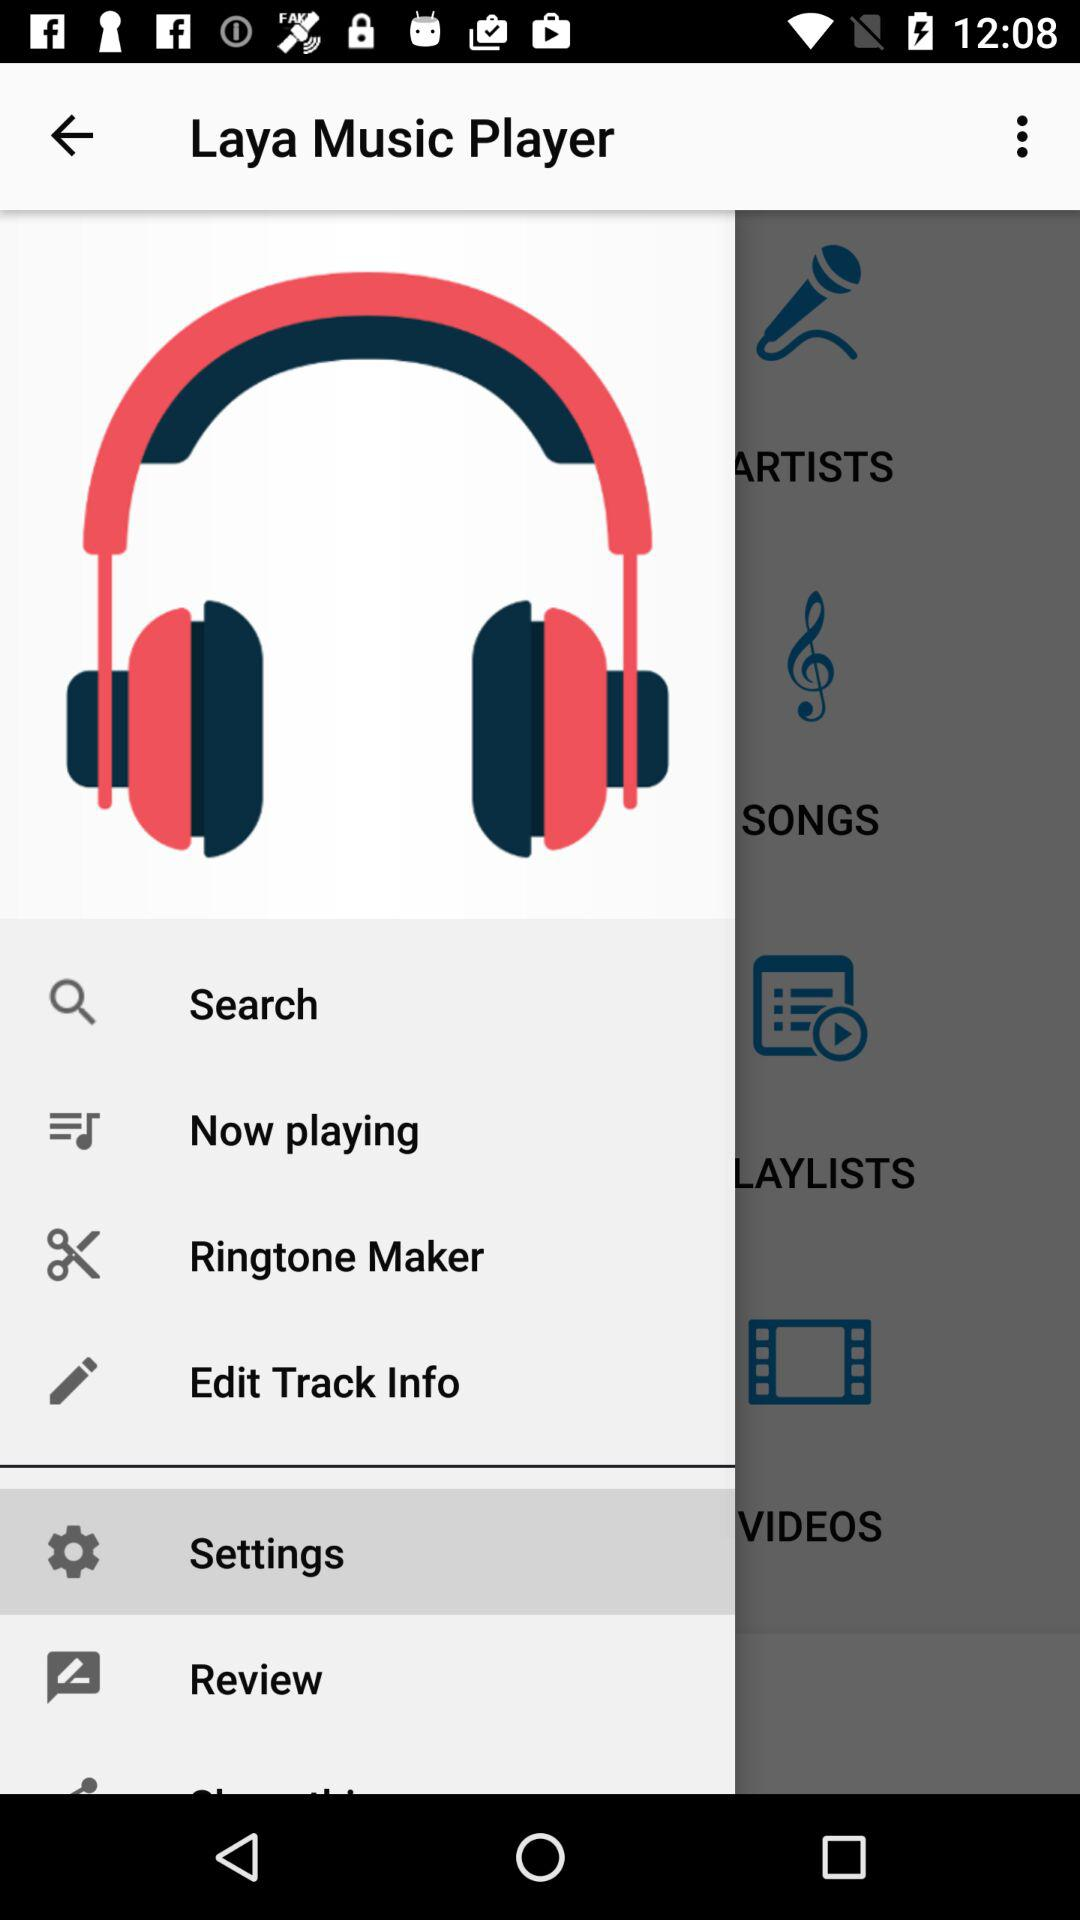What is the application name? The application name is "Laya Music Player". 